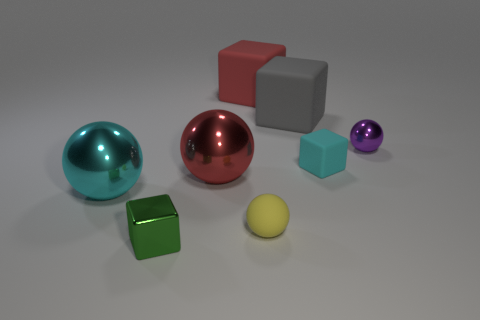Subtract 1 cubes. How many cubes are left? 3 Add 1 tiny green metallic objects. How many objects exist? 9 Add 2 matte things. How many matte things exist? 6 Subtract 0 brown cubes. How many objects are left? 8 Subtract all brown rubber spheres. Subtract all green blocks. How many objects are left? 7 Add 3 tiny matte blocks. How many tiny matte blocks are left? 4 